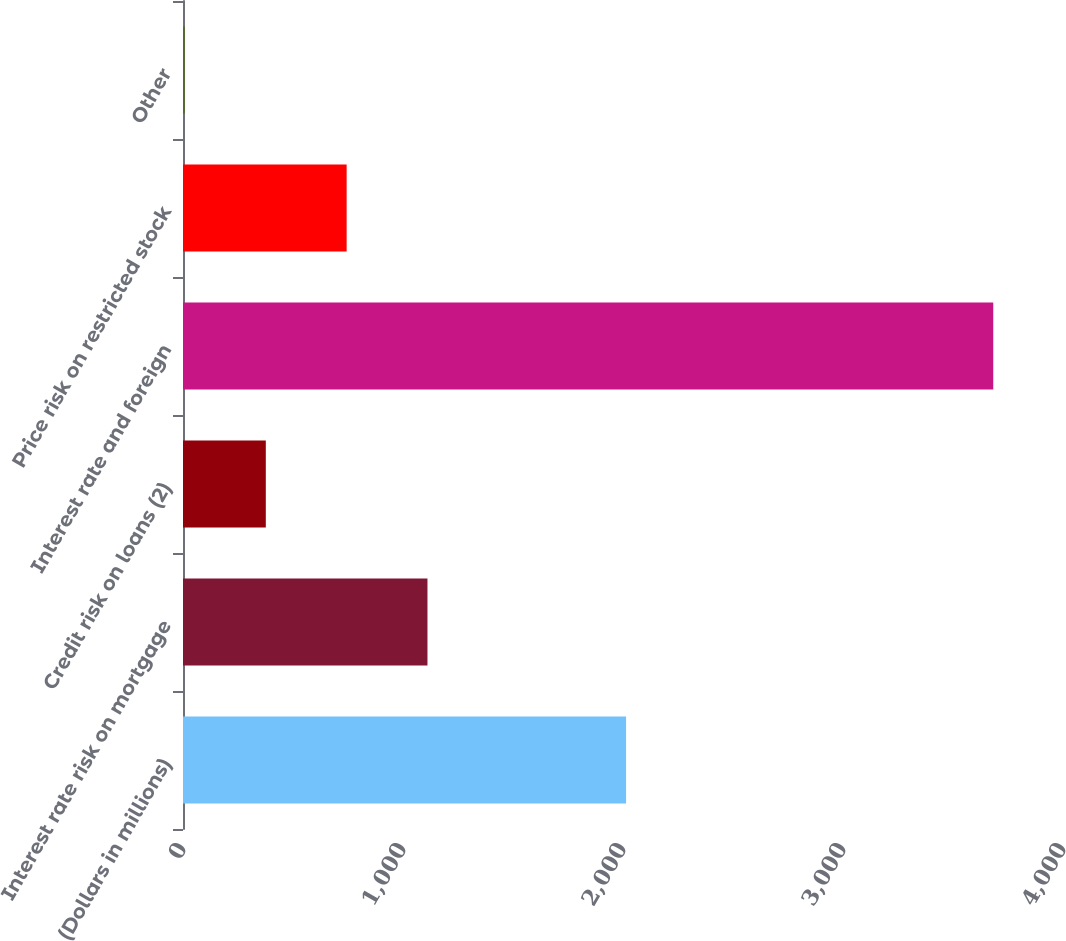<chart> <loc_0><loc_0><loc_500><loc_500><bar_chart><fcel>(Dollars in millions)<fcel>Interest rate risk on mortgage<fcel>Credit risk on loans (2)<fcel>Interest rate and foreign<fcel>Price risk on restricted stock<fcel>Other<nl><fcel>2014<fcel>1111.2<fcel>376.4<fcel>3683<fcel>743.8<fcel>9<nl></chart> 